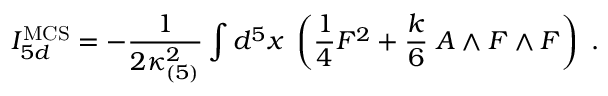Convert formula to latex. <formula><loc_0><loc_0><loc_500><loc_500>I _ { 5 d } ^ { M C S } = - { \frac { 1 } { 2 \kappa _ { ( 5 ) } ^ { 2 } } } \int d ^ { 5 } x \, \left ( { \frac { 1 } { 4 } } F ^ { 2 } + { \frac { k } { 6 } } \, A \wedge F \wedge F \right ) \ .</formula> 